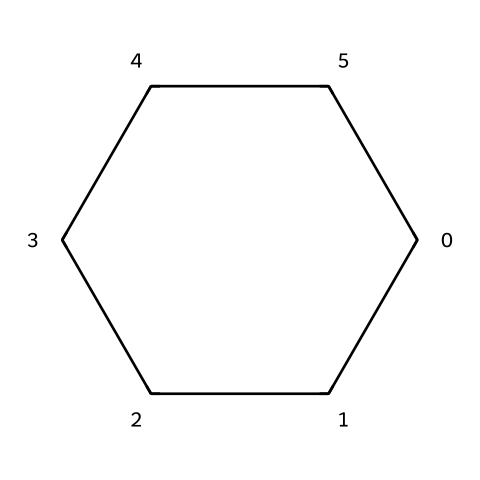What is the molecular formula of this compound? To determine the molecular formula, count the number of carbon and hydrogen atoms in the structure. The cyclohexane structure has six carbon atoms and twelve hydrogen atoms. Hence, the molecular formula is C6H12.
Answer: C6H12 How many carbon atoms are in the compound? Inspecting the structure, we see that there are six vertices in the cyclohexane ring, each representing a carbon atom. Thus, the total number of carbon atoms is six.
Answer: six What is the primary use of cyclohexane in nanotech manufacturing processes? Cyclohexane is often used as a nonpolar solvent in various manufacturing processes, facilitating the dissolution of organic compounds and polymers in nanotech.
Answer: solvent How does the ring structure of cyclohexane influence its boiling point compared to straight-chain alkanes? The ring structure of cyclohexane allows for closer packing and stronger van der Waals interactions compared to straight-chain alkanes, leading to a higher boiling point due to increased intermolecular forces.
Answer: higher boiling point Is cyclohexane classified as a saturated or unsaturated hydrocarbon? Cyclohexane contains only single bonds between its carbon atoms, with no double or triple bonds present, which classifies it as a saturated hydrocarbon.
Answer: saturated What type of chemical bonding is present in cyclohexane? The structure of cyclohexane exhibits single covalent bonds between the carbon atoms and between carbon and hydrogen atoms, indicating that it consists of covalent bonding.
Answer: covalent bonding Why is cyclohexane a suitable choice for nanotechnology applications? Cyclohexane's nonpolar nature allows it to effectively dissolve various organic materials, making it suitable for applications in nanotechnology where specific solvents are necessary to manipulate nanoparticles and coatings.
Answer: nonpolar nature 